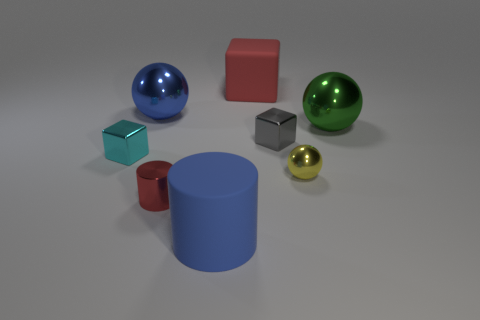Are there any objects right of the small red thing?
Your answer should be very brief. Yes. Are there any other things that are the same size as the blue cylinder?
Give a very brief answer. Yes. The big object that is the same material as the large red cube is what color?
Keep it short and to the point. Blue. There is a shiny block that is to the left of the big blue cylinder; does it have the same color as the large object in front of the big green shiny object?
Give a very brief answer. No. What number of spheres are tiny gray metallic objects or large green rubber things?
Keep it short and to the point. 0. Is the number of big green balls behind the green metallic thing the same as the number of tiny yellow metallic objects?
Your answer should be compact. No. What material is the big blue object in front of the tiny metallic block on the right side of the blue object that is behind the small yellow sphere?
Your response must be concise. Rubber. There is a tiny cylinder that is the same color as the rubber block; what material is it?
Offer a very short reply. Metal. What number of objects are either large spheres on the left side of the yellow metal object or brown metallic objects?
Your response must be concise. 1. What number of objects are red rubber things or metallic balls that are to the right of the tiny gray object?
Your response must be concise. 3. 